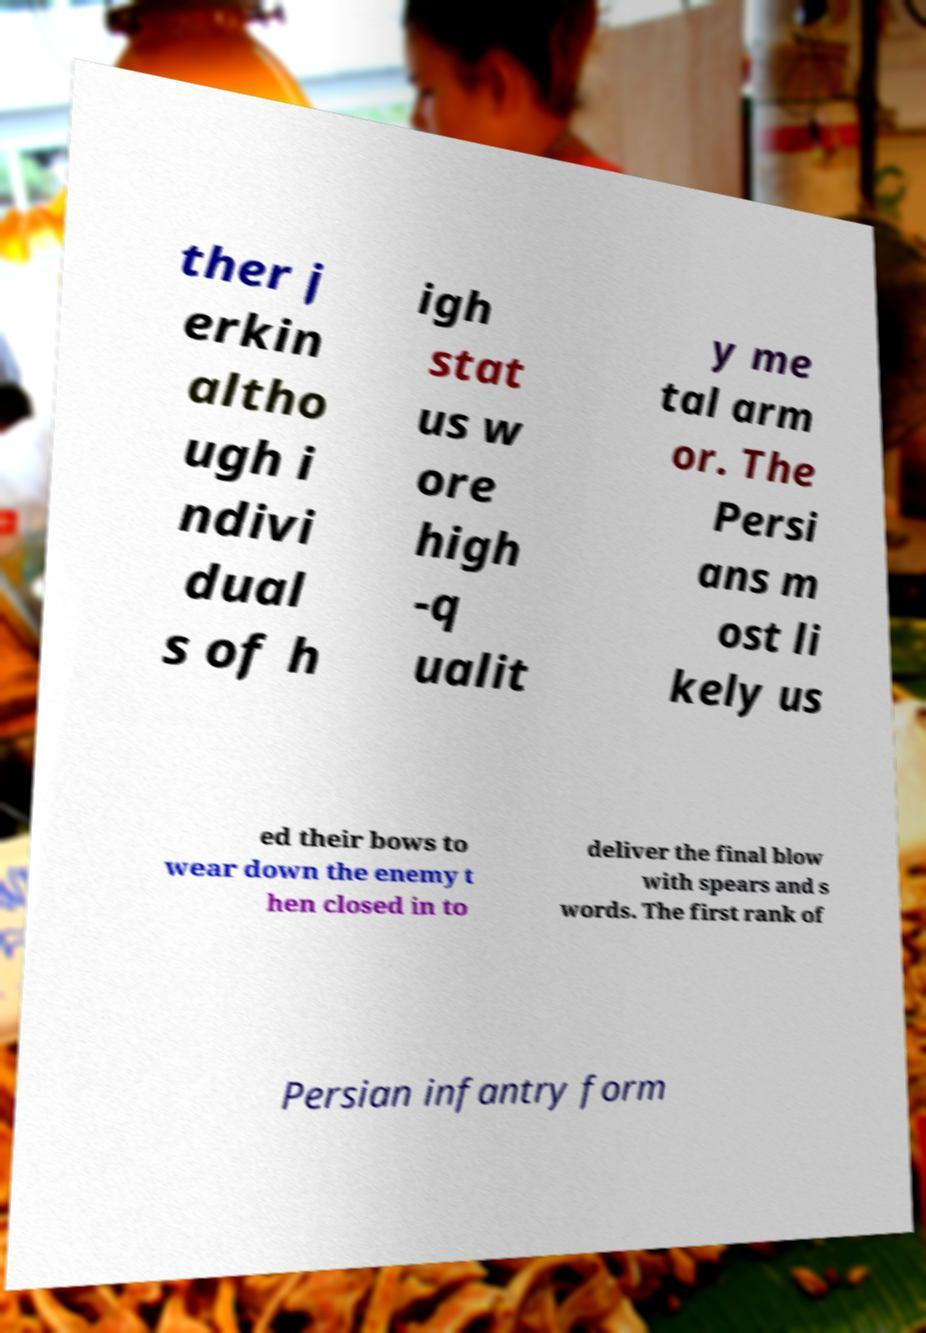I need the written content from this picture converted into text. Can you do that? ther j erkin altho ugh i ndivi dual s of h igh stat us w ore high -q ualit y me tal arm or. The Persi ans m ost li kely us ed their bows to wear down the enemy t hen closed in to deliver the final blow with spears and s words. The first rank of Persian infantry form 